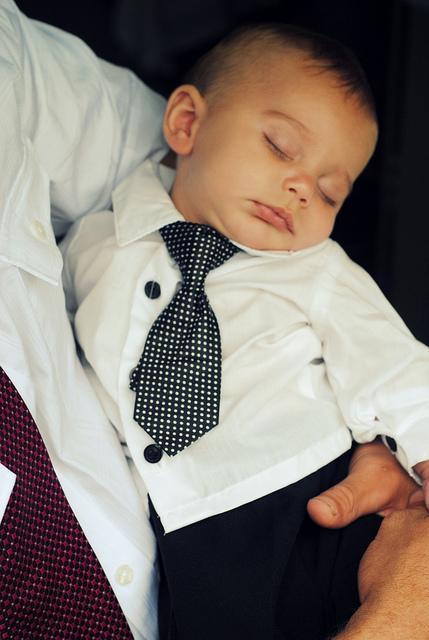How many people can be seen?
Give a very brief answer. 2. How many ties are visible?
Give a very brief answer. 2. 